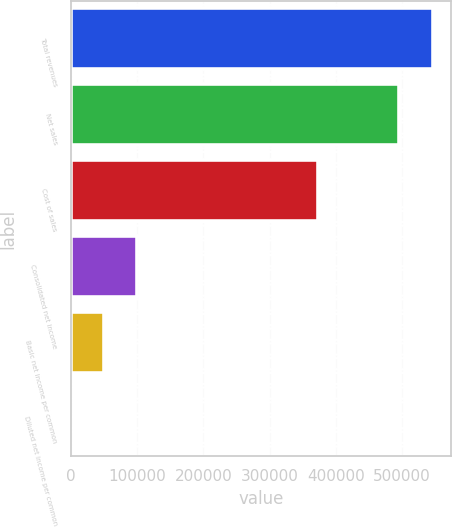Convert chart to OTSL. <chart><loc_0><loc_0><loc_500><loc_500><bar_chart><fcel>Total revenues<fcel>Net sales<fcel>Cost of sales<fcel>Consolidated net income<fcel>Basic net income per common<fcel>Diluted net income per common<nl><fcel>545795<fcel>495761<fcel>373396<fcel>100071<fcel>50037.2<fcel>3.28<nl></chart> 